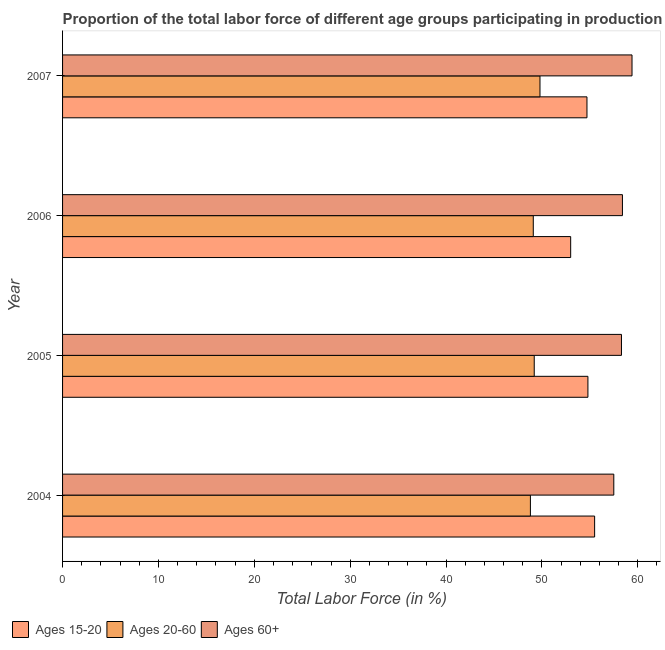How many groups of bars are there?
Provide a short and direct response. 4. Are the number of bars on each tick of the Y-axis equal?
Give a very brief answer. Yes. How many bars are there on the 2nd tick from the top?
Offer a very short reply. 3. In how many cases, is the number of bars for a given year not equal to the number of legend labels?
Give a very brief answer. 0. What is the percentage of labor force above age 60 in 2007?
Give a very brief answer. 59.4. Across all years, what is the maximum percentage of labor force within the age group 15-20?
Your answer should be very brief. 55.5. Across all years, what is the minimum percentage of labor force within the age group 20-60?
Ensure brevity in your answer.  48.8. In which year was the percentage of labor force within the age group 15-20 maximum?
Your response must be concise. 2004. What is the total percentage of labor force within the age group 20-60 in the graph?
Your response must be concise. 196.9. What is the difference between the percentage of labor force above age 60 in 2007 and the percentage of labor force within the age group 20-60 in 2004?
Your answer should be very brief. 10.6. What is the average percentage of labor force within the age group 20-60 per year?
Ensure brevity in your answer.  49.23. What is the ratio of the percentage of labor force above age 60 in 2004 to that in 2006?
Give a very brief answer. 0.98. Is the percentage of labor force within the age group 15-20 in 2005 less than that in 2006?
Ensure brevity in your answer.  No. Is the difference between the percentage of labor force above age 60 in 2004 and 2005 greater than the difference between the percentage of labor force within the age group 20-60 in 2004 and 2005?
Offer a very short reply. No. What is the difference between the highest and the lowest percentage of labor force above age 60?
Make the answer very short. 1.9. In how many years, is the percentage of labor force above age 60 greater than the average percentage of labor force above age 60 taken over all years?
Your answer should be very brief. 2. What does the 1st bar from the top in 2006 represents?
Your answer should be compact. Ages 60+. What does the 2nd bar from the bottom in 2007 represents?
Provide a short and direct response. Ages 20-60. Is it the case that in every year, the sum of the percentage of labor force within the age group 15-20 and percentage of labor force within the age group 20-60 is greater than the percentage of labor force above age 60?
Give a very brief answer. Yes. How many bars are there?
Offer a very short reply. 12. What is the difference between two consecutive major ticks on the X-axis?
Your answer should be compact. 10. Does the graph contain any zero values?
Make the answer very short. No. Does the graph contain grids?
Ensure brevity in your answer.  No. How many legend labels are there?
Offer a very short reply. 3. How are the legend labels stacked?
Provide a short and direct response. Horizontal. What is the title of the graph?
Keep it short and to the point. Proportion of the total labor force of different age groups participating in production in Malta. What is the Total Labor Force (in %) of Ages 15-20 in 2004?
Ensure brevity in your answer.  55.5. What is the Total Labor Force (in %) of Ages 20-60 in 2004?
Ensure brevity in your answer.  48.8. What is the Total Labor Force (in %) of Ages 60+ in 2004?
Keep it short and to the point. 57.5. What is the Total Labor Force (in %) of Ages 15-20 in 2005?
Make the answer very short. 54.8. What is the Total Labor Force (in %) of Ages 20-60 in 2005?
Keep it short and to the point. 49.2. What is the Total Labor Force (in %) in Ages 60+ in 2005?
Ensure brevity in your answer.  58.3. What is the Total Labor Force (in %) of Ages 15-20 in 2006?
Make the answer very short. 53. What is the Total Labor Force (in %) of Ages 20-60 in 2006?
Make the answer very short. 49.1. What is the Total Labor Force (in %) of Ages 60+ in 2006?
Give a very brief answer. 58.4. What is the Total Labor Force (in %) in Ages 15-20 in 2007?
Your answer should be compact. 54.7. What is the Total Labor Force (in %) in Ages 20-60 in 2007?
Offer a terse response. 49.8. What is the Total Labor Force (in %) in Ages 60+ in 2007?
Offer a terse response. 59.4. Across all years, what is the maximum Total Labor Force (in %) of Ages 15-20?
Offer a very short reply. 55.5. Across all years, what is the maximum Total Labor Force (in %) of Ages 20-60?
Offer a very short reply. 49.8. Across all years, what is the maximum Total Labor Force (in %) in Ages 60+?
Make the answer very short. 59.4. Across all years, what is the minimum Total Labor Force (in %) in Ages 20-60?
Provide a succinct answer. 48.8. Across all years, what is the minimum Total Labor Force (in %) of Ages 60+?
Provide a short and direct response. 57.5. What is the total Total Labor Force (in %) in Ages 15-20 in the graph?
Make the answer very short. 218. What is the total Total Labor Force (in %) of Ages 20-60 in the graph?
Your response must be concise. 196.9. What is the total Total Labor Force (in %) of Ages 60+ in the graph?
Your response must be concise. 233.6. What is the difference between the Total Labor Force (in %) in Ages 15-20 in 2004 and that in 2006?
Make the answer very short. 2.5. What is the difference between the Total Labor Force (in %) of Ages 20-60 in 2004 and that in 2006?
Keep it short and to the point. -0.3. What is the difference between the Total Labor Force (in %) of Ages 60+ in 2004 and that in 2006?
Make the answer very short. -0.9. What is the difference between the Total Labor Force (in %) of Ages 15-20 in 2004 and that in 2007?
Your answer should be very brief. 0.8. What is the difference between the Total Labor Force (in %) of Ages 60+ in 2004 and that in 2007?
Offer a terse response. -1.9. What is the difference between the Total Labor Force (in %) in Ages 15-20 in 2005 and that in 2006?
Offer a very short reply. 1.8. What is the difference between the Total Labor Force (in %) of Ages 20-60 in 2005 and that in 2006?
Give a very brief answer. 0.1. What is the difference between the Total Labor Force (in %) of Ages 15-20 in 2005 and that in 2007?
Provide a succinct answer. 0.1. What is the difference between the Total Labor Force (in %) in Ages 15-20 in 2006 and that in 2007?
Keep it short and to the point. -1.7. What is the difference between the Total Labor Force (in %) of Ages 20-60 in 2006 and that in 2007?
Provide a short and direct response. -0.7. What is the difference between the Total Labor Force (in %) in Ages 15-20 in 2004 and the Total Labor Force (in %) in Ages 20-60 in 2005?
Offer a very short reply. 6.3. What is the difference between the Total Labor Force (in %) in Ages 20-60 in 2004 and the Total Labor Force (in %) in Ages 60+ in 2005?
Your answer should be very brief. -9.5. What is the difference between the Total Labor Force (in %) of Ages 15-20 in 2004 and the Total Labor Force (in %) of Ages 20-60 in 2006?
Offer a terse response. 6.4. What is the difference between the Total Labor Force (in %) of Ages 15-20 in 2004 and the Total Labor Force (in %) of Ages 20-60 in 2007?
Make the answer very short. 5.7. What is the difference between the Total Labor Force (in %) in Ages 20-60 in 2004 and the Total Labor Force (in %) in Ages 60+ in 2007?
Your answer should be very brief. -10.6. What is the difference between the Total Labor Force (in %) in Ages 20-60 in 2005 and the Total Labor Force (in %) in Ages 60+ in 2006?
Your answer should be compact. -9.2. What is the difference between the Total Labor Force (in %) in Ages 15-20 in 2005 and the Total Labor Force (in %) in Ages 20-60 in 2007?
Keep it short and to the point. 5. What is the difference between the Total Labor Force (in %) in Ages 15-20 in 2005 and the Total Labor Force (in %) in Ages 60+ in 2007?
Provide a short and direct response. -4.6. What is the difference between the Total Labor Force (in %) in Ages 15-20 in 2006 and the Total Labor Force (in %) in Ages 20-60 in 2007?
Your answer should be compact. 3.2. What is the average Total Labor Force (in %) in Ages 15-20 per year?
Ensure brevity in your answer.  54.5. What is the average Total Labor Force (in %) in Ages 20-60 per year?
Offer a terse response. 49.23. What is the average Total Labor Force (in %) of Ages 60+ per year?
Give a very brief answer. 58.4. In the year 2005, what is the difference between the Total Labor Force (in %) in Ages 15-20 and Total Labor Force (in %) in Ages 20-60?
Your response must be concise. 5.6. In the year 2005, what is the difference between the Total Labor Force (in %) in Ages 15-20 and Total Labor Force (in %) in Ages 60+?
Provide a short and direct response. -3.5. In the year 2006, what is the difference between the Total Labor Force (in %) of Ages 15-20 and Total Labor Force (in %) of Ages 60+?
Provide a short and direct response. -5.4. In the year 2006, what is the difference between the Total Labor Force (in %) in Ages 20-60 and Total Labor Force (in %) in Ages 60+?
Your answer should be compact. -9.3. In the year 2007, what is the difference between the Total Labor Force (in %) of Ages 15-20 and Total Labor Force (in %) of Ages 20-60?
Provide a succinct answer. 4.9. In the year 2007, what is the difference between the Total Labor Force (in %) in Ages 15-20 and Total Labor Force (in %) in Ages 60+?
Provide a succinct answer. -4.7. What is the ratio of the Total Labor Force (in %) in Ages 15-20 in 2004 to that in 2005?
Ensure brevity in your answer.  1.01. What is the ratio of the Total Labor Force (in %) of Ages 60+ in 2004 to that in 2005?
Give a very brief answer. 0.99. What is the ratio of the Total Labor Force (in %) of Ages 15-20 in 2004 to that in 2006?
Make the answer very short. 1.05. What is the ratio of the Total Labor Force (in %) in Ages 60+ in 2004 to that in 2006?
Your answer should be very brief. 0.98. What is the ratio of the Total Labor Force (in %) of Ages 15-20 in 2004 to that in 2007?
Give a very brief answer. 1.01. What is the ratio of the Total Labor Force (in %) in Ages 20-60 in 2004 to that in 2007?
Give a very brief answer. 0.98. What is the ratio of the Total Labor Force (in %) of Ages 60+ in 2004 to that in 2007?
Your answer should be compact. 0.97. What is the ratio of the Total Labor Force (in %) in Ages 15-20 in 2005 to that in 2006?
Provide a short and direct response. 1.03. What is the ratio of the Total Labor Force (in %) of Ages 60+ in 2005 to that in 2006?
Make the answer very short. 1. What is the ratio of the Total Labor Force (in %) of Ages 20-60 in 2005 to that in 2007?
Provide a short and direct response. 0.99. What is the ratio of the Total Labor Force (in %) in Ages 60+ in 2005 to that in 2007?
Provide a succinct answer. 0.98. What is the ratio of the Total Labor Force (in %) of Ages 15-20 in 2006 to that in 2007?
Ensure brevity in your answer.  0.97. What is the ratio of the Total Labor Force (in %) in Ages 20-60 in 2006 to that in 2007?
Offer a terse response. 0.99. What is the ratio of the Total Labor Force (in %) in Ages 60+ in 2006 to that in 2007?
Offer a terse response. 0.98. What is the difference between the highest and the second highest Total Labor Force (in %) of Ages 15-20?
Your response must be concise. 0.7. What is the difference between the highest and the second highest Total Labor Force (in %) of Ages 20-60?
Ensure brevity in your answer.  0.6. What is the difference between the highest and the second highest Total Labor Force (in %) in Ages 60+?
Provide a short and direct response. 1. What is the difference between the highest and the lowest Total Labor Force (in %) in Ages 60+?
Make the answer very short. 1.9. 